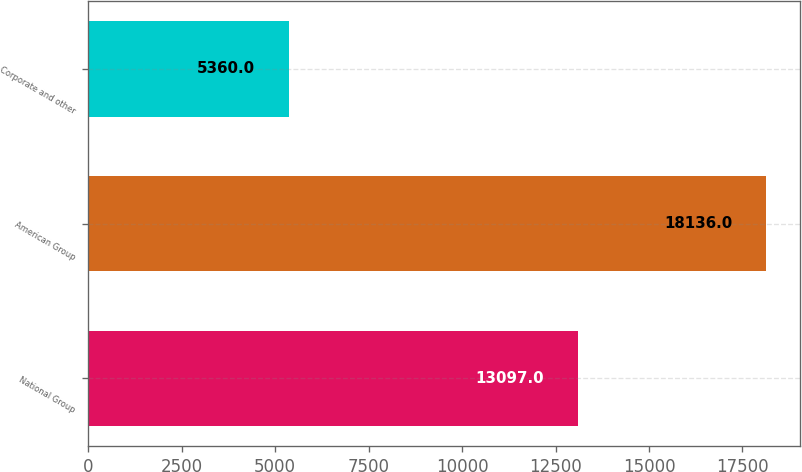Convert chart. <chart><loc_0><loc_0><loc_500><loc_500><bar_chart><fcel>National Group<fcel>American Group<fcel>Corporate and other<nl><fcel>13097<fcel>18136<fcel>5360<nl></chart> 